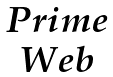Convert formula to latex. <formula><loc_0><loc_0><loc_500><loc_500>\begin{matrix} P r i m e \\ W e b \end{matrix}</formula> 